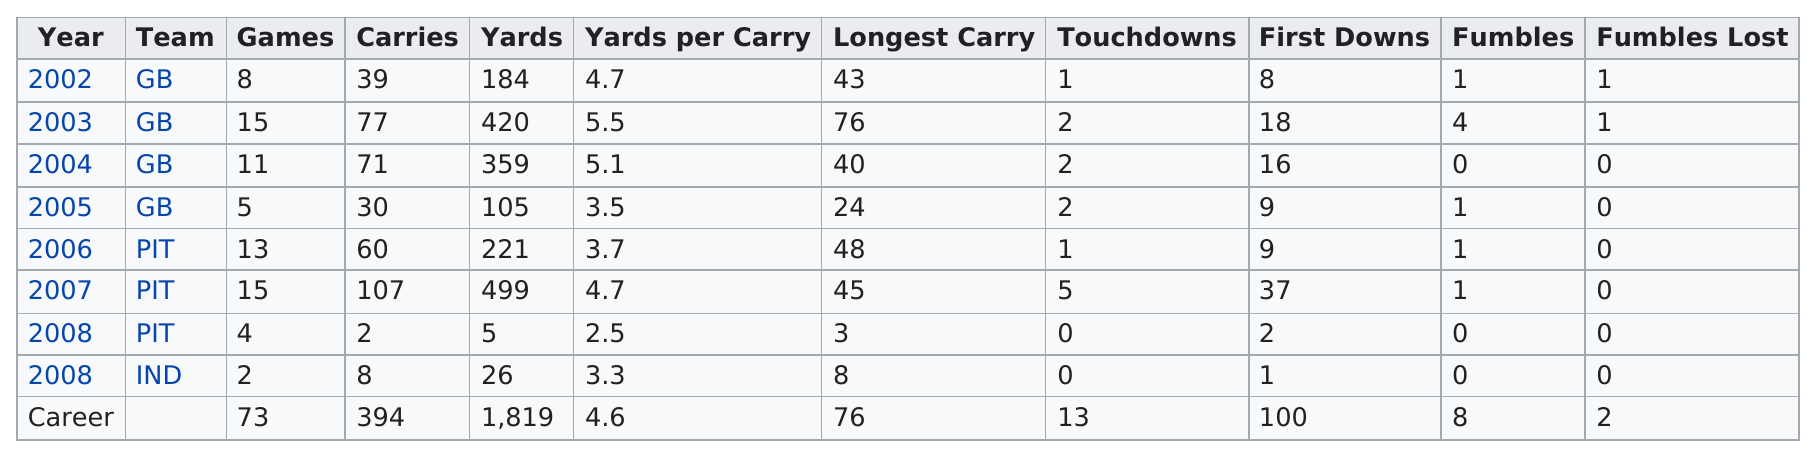Draw attention to some important aspects in this diagram. In the years 2002 and 2007, the average number of yards per carry was the same. In the year 2002, the player played at least 8 games. The word that is next to "carries" is "yards." The number of touchdowns in 2002 is higher than the number of touchdowns in 2008. In 2002, the number of games played by him was greater than the amount played in 2008, and he played more games. 